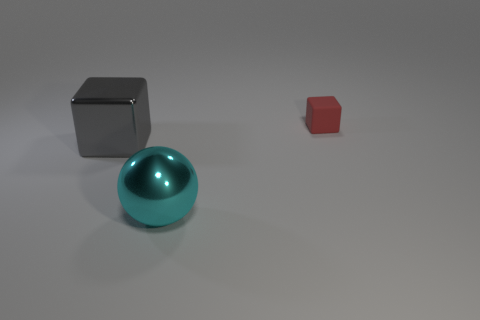Subtract all red blocks. How many blocks are left? 1 Add 3 red rubber objects. How many objects exist? 6 Subtract all red balls. How many green cubes are left? 0 Subtract all big gray rubber cylinders. Subtract all large blocks. How many objects are left? 2 Add 1 gray shiny blocks. How many gray shiny blocks are left? 2 Add 2 gray cubes. How many gray cubes exist? 3 Subtract 0 green balls. How many objects are left? 3 Subtract all balls. How many objects are left? 2 Subtract 1 cubes. How many cubes are left? 1 Subtract all cyan cubes. Subtract all green cylinders. How many cubes are left? 2 